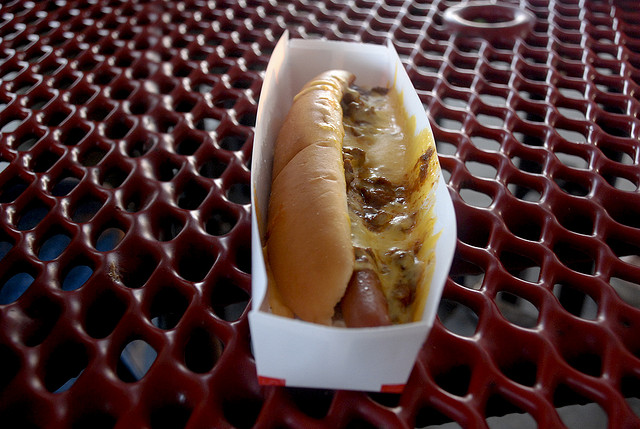How many cars are parked? The image does not show any cars being parked; instead, it depicts a hot dog with toppings in a container, placed on a red patterned metal table. 